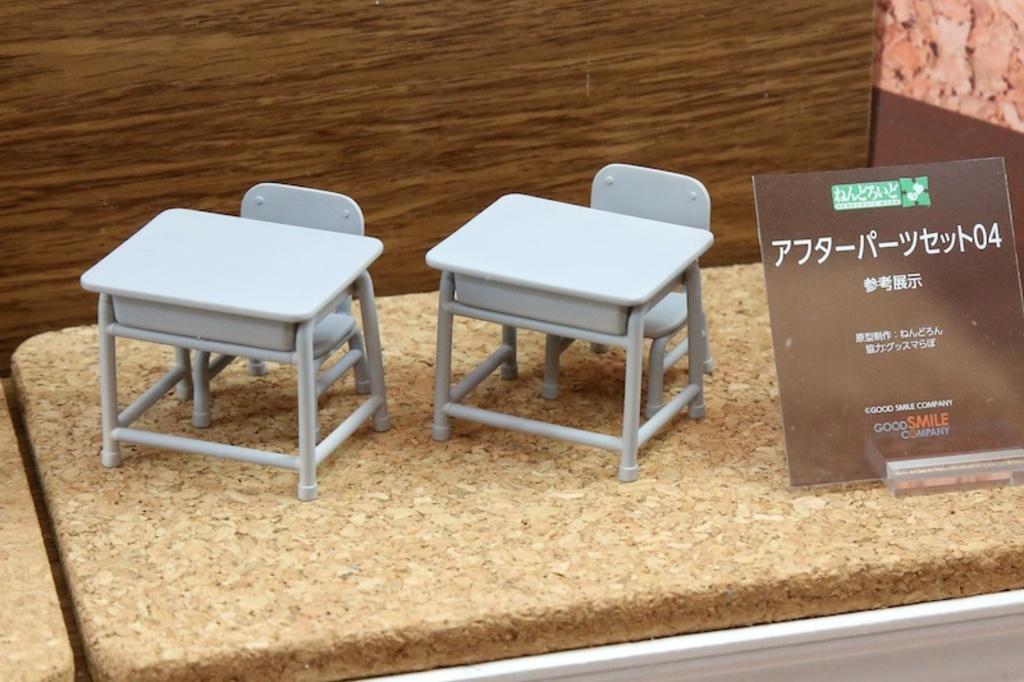How would you summarize this image in a sentence or two? This picture looks like couple of miniature tables and chairs on the wood and I can see a board with some text and I can see wooden background. 